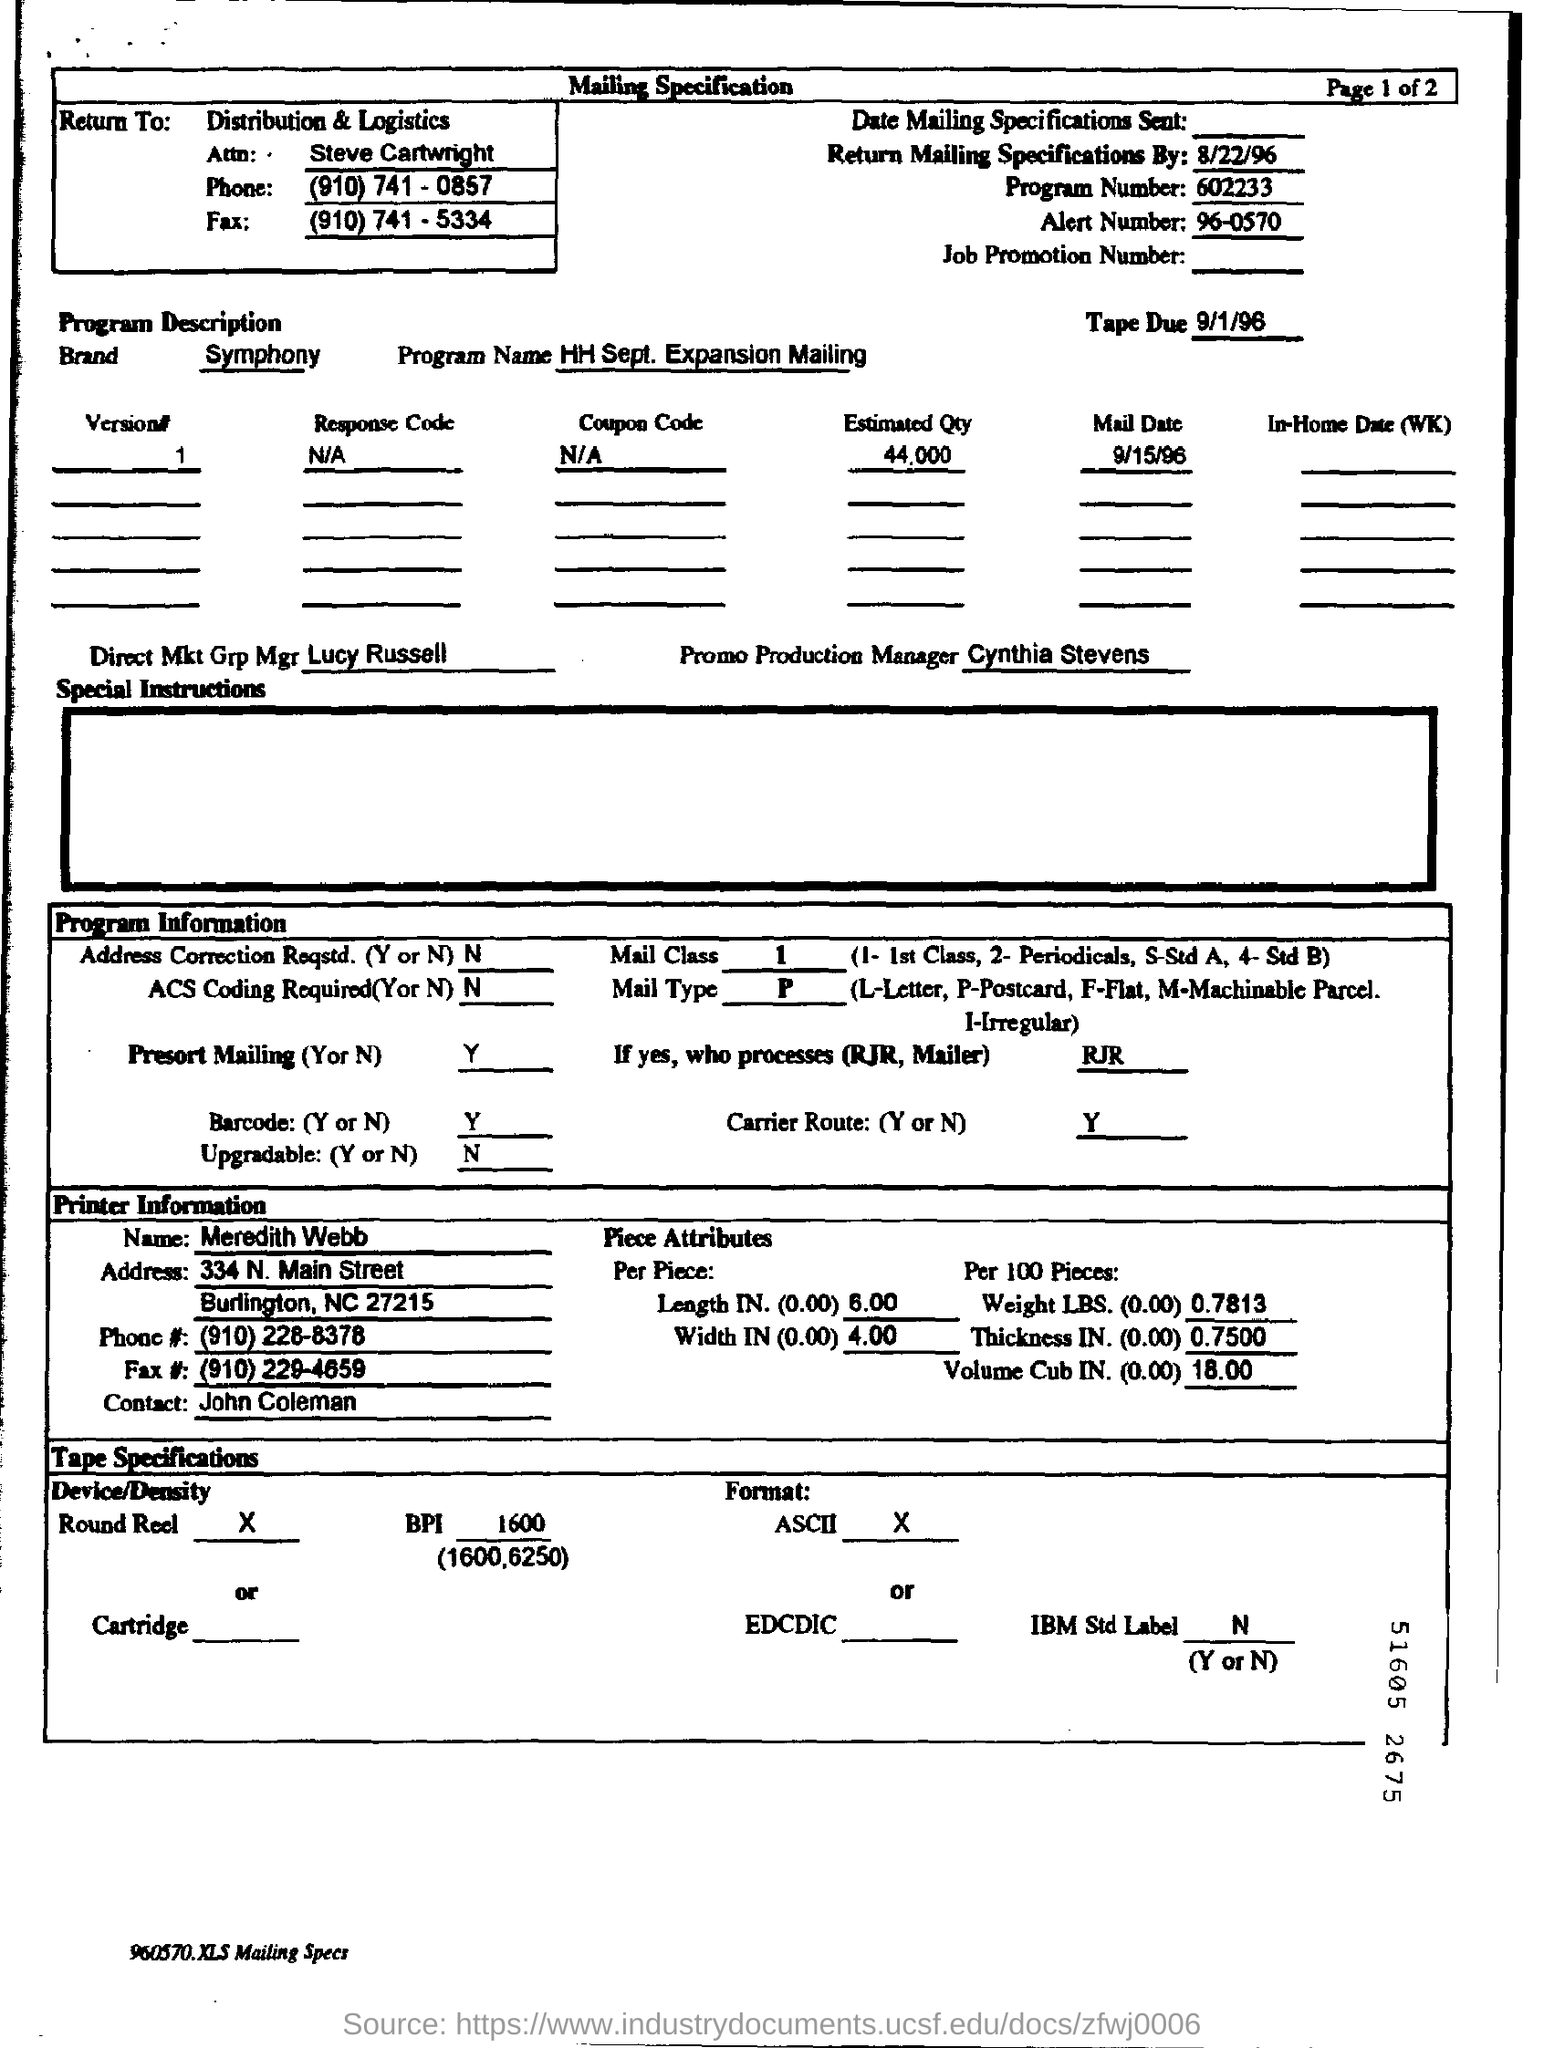What is the program Number mentioned in this document?
Provide a short and direct response. 602233. What is the alert number mentioned here?
Keep it short and to the point. 96-0570. Who is  the Promo Production Manager?
Provide a short and direct response. Cynthia stevens. Which Brand is given in this document?
Your response must be concise. Symphony. What is the Program Name?
Keep it short and to the point. HH sept . Expansion mailing. Who is Direct Mkt Grp Mgr?
Your response must be concise. Lucy russell. When is the Tape Due?
Give a very brief answer. 9/1/96. What is the Estimated Qty as per the document?
Your answer should be very brief. 44,000. 